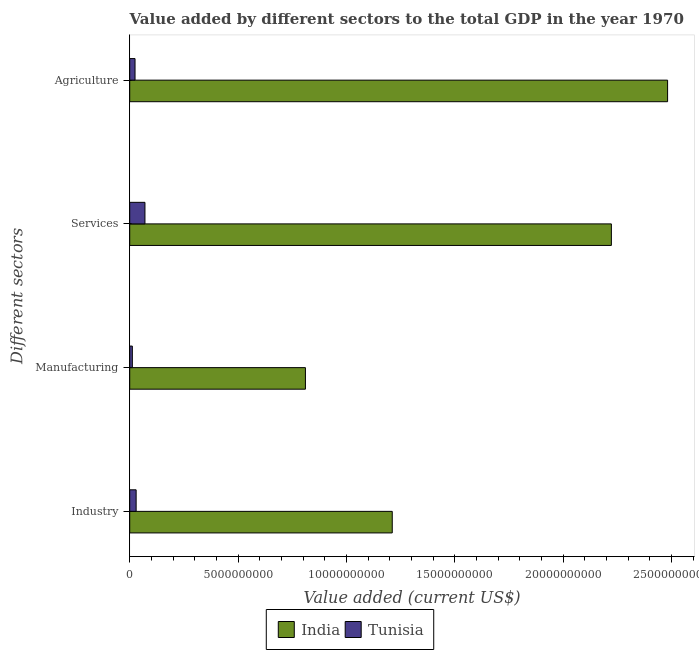How many groups of bars are there?
Your answer should be compact. 4. Are the number of bars on each tick of the Y-axis equal?
Give a very brief answer. Yes. What is the label of the 4th group of bars from the top?
Provide a short and direct response. Industry. What is the value added by services sector in India?
Your answer should be compact. 2.22e+1. Across all countries, what is the maximum value added by agricultural sector?
Provide a succinct answer. 2.48e+1. Across all countries, what is the minimum value added by industrial sector?
Make the answer very short. 2.96e+08. In which country was the value added by services sector minimum?
Ensure brevity in your answer.  Tunisia. What is the total value added by services sector in the graph?
Keep it short and to the point. 2.29e+1. What is the difference between the value added by industrial sector in Tunisia and that in India?
Make the answer very short. -1.18e+1. What is the difference between the value added by services sector in India and the value added by industrial sector in Tunisia?
Offer a very short reply. 2.19e+1. What is the average value added by industrial sector per country?
Ensure brevity in your answer.  6.21e+09. What is the difference between the value added by services sector and value added by agricultural sector in India?
Your answer should be very brief. -2.60e+09. In how many countries, is the value added by services sector greater than 13000000000 US$?
Your answer should be compact. 1. What is the ratio of the value added by agricultural sector in India to that in Tunisia?
Give a very brief answer. 101.28. Is the difference between the value added by industrial sector in Tunisia and India greater than the difference between the value added by services sector in Tunisia and India?
Provide a short and direct response. Yes. What is the difference between the highest and the second highest value added by services sector?
Offer a very short reply. 2.15e+1. What is the difference between the highest and the lowest value added by agricultural sector?
Give a very brief answer. 2.46e+1. In how many countries, is the value added by manufacturing sector greater than the average value added by manufacturing sector taken over all countries?
Ensure brevity in your answer.  1. Is the sum of the value added by services sector in India and Tunisia greater than the maximum value added by industrial sector across all countries?
Keep it short and to the point. Yes. Is it the case that in every country, the sum of the value added by services sector and value added by manufacturing sector is greater than the sum of value added by agricultural sector and value added by industrial sector?
Your response must be concise. No. What does the 2nd bar from the bottom in Industry represents?
Offer a terse response. Tunisia. Is it the case that in every country, the sum of the value added by industrial sector and value added by manufacturing sector is greater than the value added by services sector?
Make the answer very short. No. How many bars are there?
Provide a succinct answer. 8. Are the values on the major ticks of X-axis written in scientific E-notation?
Your answer should be very brief. No. Does the graph contain any zero values?
Provide a short and direct response. No. Where does the legend appear in the graph?
Offer a very short reply. Bottom center. How many legend labels are there?
Your answer should be very brief. 2. How are the legend labels stacked?
Your response must be concise. Horizontal. What is the title of the graph?
Your answer should be compact. Value added by different sectors to the total GDP in the year 1970. What is the label or title of the X-axis?
Provide a succinct answer. Value added (current US$). What is the label or title of the Y-axis?
Provide a succinct answer. Different sectors. What is the Value added (current US$) in India in Industry?
Offer a terse response. 1.21e+1. What is the Value added (current US$) of Tunisia in Industry?
Your answer should be compact. 2.96e+08. What is the Value added (current US$) of India in Manufacturing?
Your answer should be compact. 8.11e+09. What is the Value added (current US$) of Tunisia in Manufacturing?
Ensure brevity in your answer.  1.21e+08. What is the Value added (current US$) in India in Services?
Provide a succinct answer. 2.22e+1. What is the Value added (current US$) of Tunisia in Services?
Offer a very short reply. 7.03e+08. What is the Value added (current US$) in India in Agriculture?
Your answer should be very brief. 2.48e+1. What is the Value added (current US$) of Tunisia in Agriculture?
Offer a very short reply. 2.45e+08. Across all Different sectors, what is the maximum Value added (current US$) of India?
Give a very brief answer. 2.48e+1. Across all Different sectors, what is the maximum Value added (current US$) of Tunisia?
Your response must be concise. 7.03e+08. Across all Different sectors, what is the minimum Value added (current US$) in India?
Your answer should be compact. 8.11e+09. Across all Different sectors, what is the minimum Value added (current US$) in Tunisia?
Your answer should be very brief. 1.21e+08. What is the total Value added (current US$) of India in the graph?
Keep it short and to the point. 6.73e+1. What is the total Value added (current US$) in Tunisia in the graph?
Offer a very short reply. 1.37e+09. What is the difference between the Value added (current US$) of India in Industry and that in Manufacturing?
Make the answer very short. 4.01e+09. What is the difference between the Value added (current US$) of Tunisia in Industry and that in Manufacturing?
Keep it short and to the point. 1.75e+08. What is the difference between the Value added (current US$) of India in Industry and that in Services?
Your response must be concise. -1.01e+1. What is the difference between the Value added (current US$) of Tunisia in Industry and that in Services?
Your response must be concise. -4.07e+08. What is the difference between the Value added (current US$) in India in Industry and that in Agriculture?
Your answer should be compact. -1.27e+1. What is the difference between the Value added (current US$) in Tunisia in Industry and that in Agriculture?
Offer a terse response. 5.10e+07. What is the difference between the Value added (current US$) in India in Manufacturing and that in Services?
Your answer should be very brief. -1.41e+1. What is the difference between the Value added (current US$) in Tunisia in Manufacturing and that in Services?
Keep it short and to the point. -5.82e+08. What is the difference between the Value added (current US$) of India in Manufacturing and that in Agriculture?
Provide a short and direct response. -1.67e+1. What is the difference between the Value added (current US$) in Tunisia in Manufacturing and that in Agriculture?
Keep it short and to the point. -1.24e+08. What is the difference between the Value added (current US$) in India in Services and that in Agriculture?
Your answer should be very brief. -2.60e+09. What is the difference between the Value added (current US$) of Tunisia in Services and that in Agriculture?
Provide a succinct answer. 4.58e+08. What is the difference between the Value added (current US$) in India in Industry and the Value added (current US$) in Tunisia in Manufacturing?
Offer a terse response. 1.20e+1. What is the difference between the Value added (current US$) of India in Industry and the Value added (current US$) of Tunisia in Services?
Offer a terse response. 1.14e+1. What is the difference between the Value added (current US$) in India in Industry and the Value added (current US$) in Tunisia in Agriculture?
Your answer should be very brief. 1.19e+1. What is the difference between the Value added (current US$) of India in Manufacturing and the Value added (current US$) of Tunisia in Services?
Your answer should be compact. 7.41e+09. What is the difference between the Value added (current US$) in India in Manufacturing and the Value added (current US$) in Tunisia in Agriculture?
Ensure brevity in your answer.  7.86e+09. What is the difference between the Value added (current US$) in India in Services and the Value added (current US$) in Tunisia in Agriculture?
Your answer should be compact. 2.20e+1. What is the average Value added (current US$) of India per Different sectors?
Give a very brief answer. 1.68e+1. What is the average Value added (current US$) of Tunisia per Different sectors?
Give a very brief answer. 3.41e+08. What is the difference between the Value added (current US$) of India and Value added (current US$) of Tunisia in Industry?
Provide a short and direct response. 1.18e+1. What is the difference between the Value added (current US$) in India and Value added (current US$) in Tunisia in Manufacturing?
Your answer should be compact. 7.99e+09. What is the difference between the Value added (current US$) of India and Value added (current US$) of Tunisia in Services?
Your answer should be compact. 2.15e+1. What is the difference between the Value added (current US$) of India and Value added (current US$) of Tunisia in Agriculture?
Offer a terse response. 2.46e+1. What is the ratio of the Value added (current US$) of India in Industry to that in Manufacturing?
Keep it short and to the point. 1.49. What is the ratio of the Value added (current US$) of Tunisia in Industry to that in Manufacturing?
Give a very brief answer. 2.45. What is the ratio of the Value added (current US$) of India in Industry to that in Services?
Ensure brevity in your answer.  0.55. What is the ratio of the Value added (current US$) in Tunisia in Industry to that in Services?
Offer a very short reply. 0.42. What is the ratio of the Value added (current US$) in India in Industry to that in Agriculture?
Your response must be concise. 0.49. What is the ratio of the Value added (current US$) of Tunisia in Industry to that in Agriculture?
Your response must be concise. 1.21. What is the ratio of the Value added (current US$) of India in Manufacturing to that in Services?
Your response must be concise. 0.36. What is the ratio of the Value added (current US$) of Tunisia in Manufacturing to that in Services?
Provide a succinct answer. 0.17. What is the ratio of the Value added (current US$) of India in Manufacturing to that in Agriculture?
Provide a succinct answer. 0.33. What is the ratio of the Value added (current US$) of Tunisia in Manufacturing to that in Agriculture?
Your answer should be very brief. 0.49. What is the ratio of the Value added (current US$) of India in Services to that in Agriculture?
Offer a terse response. 0.9. What is the ratio of the Value added (current US$) of Tunisia in Services to that in Agriculture?
Make the answer very short. 2.87. What is the difference between the highest and the second highest Value added (current US$) of India?
Ensure brevity in your answer.  2.60e+09. What is the difference between the highest and the second highest Value added (current US$) in Tunisia?
Provide a short and direct response. 4.07e+08. What is the difference between the highest and the lowest Value added (current US$) of India?
Provide a short and direct response. 1.67e+1. What is the difference between the highest and the lowest Value added (current US$) of Tunisia?
Provide a succinct answer. 5.82e+08. 